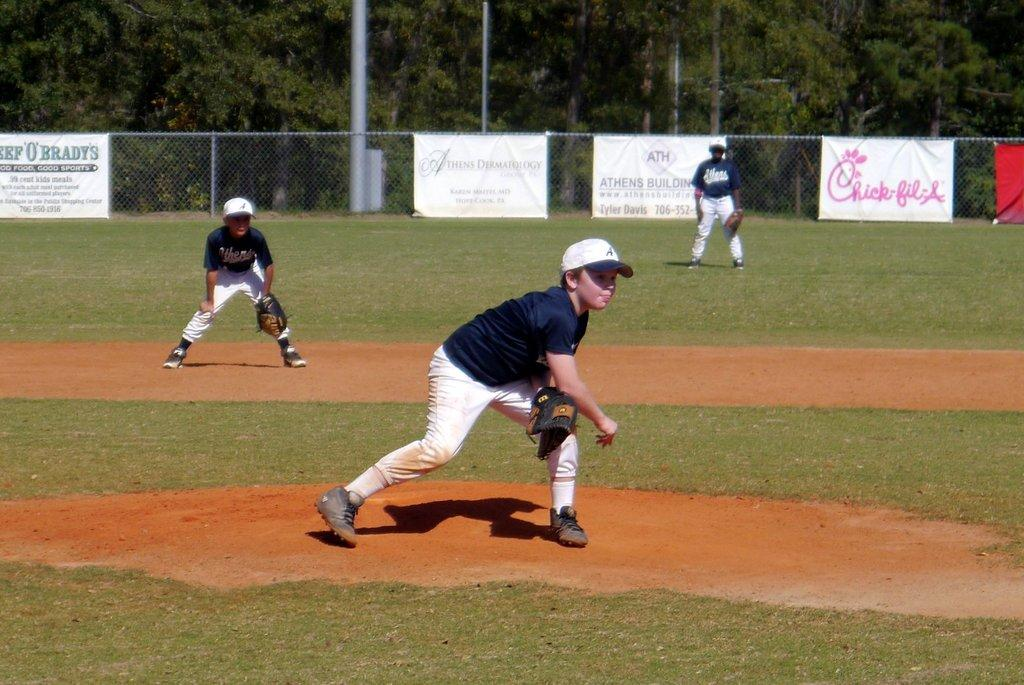<image>
Share a concise interpretation of the image provided. A young pitcher takes the mound in a little league game where banner sponsors include Chick-fil-a. 